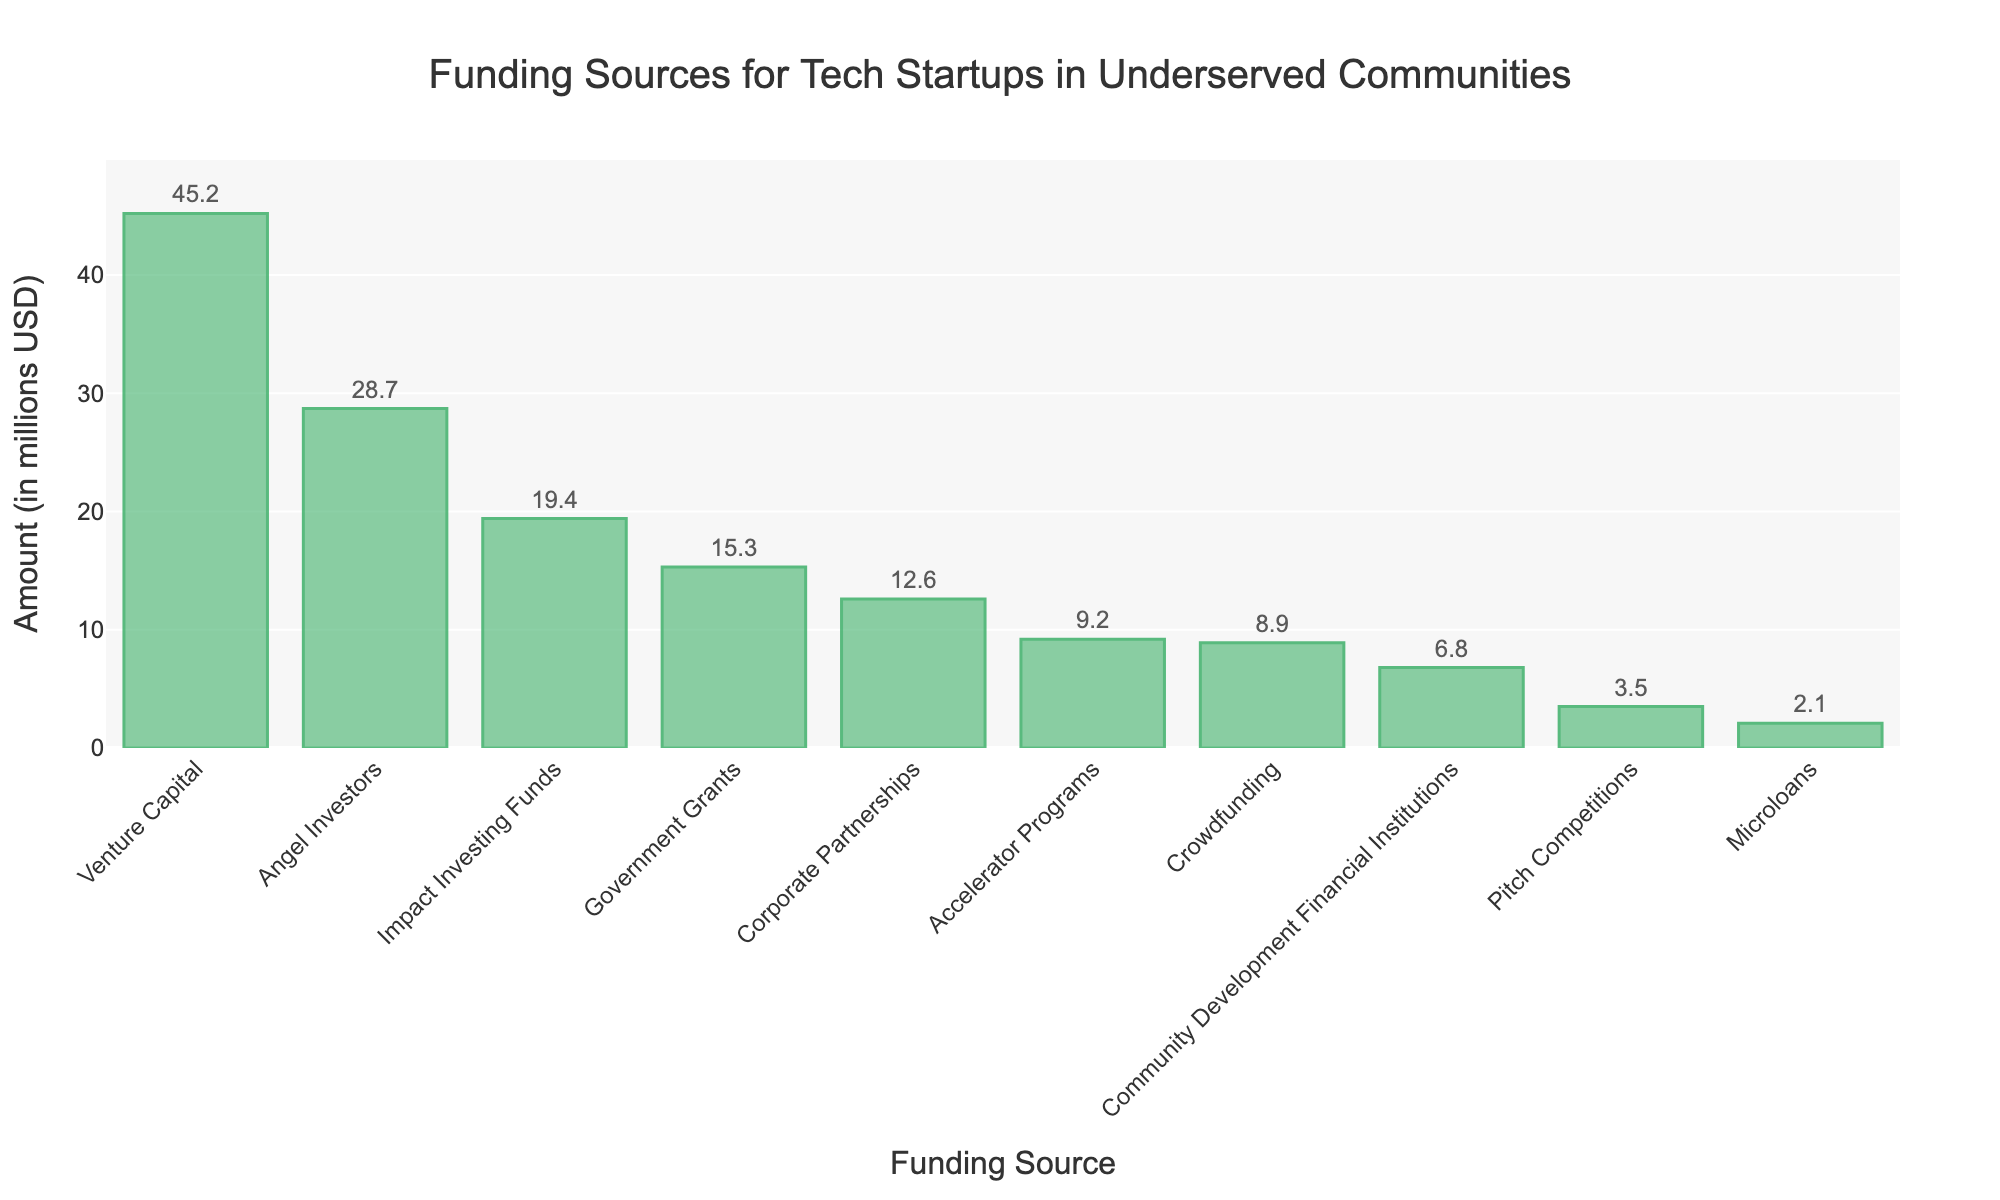Which funding source received the highest amount? Observe the heights of all the bars. The bar labeled "Venture Capital" is the tallest, indicating it received the highest amount of funding.
Answer: Venture Capital What is the combined amount of funding from Government Grants, Corporate Partnerships, and Crowdfunding? Identify the heights of the bars for Government Grants (15.3 million USD), Corporate Partnerships (12.6 million USD), and Crowdfunding (8.9 million USD). Add these amounts together: 15.3 + 12.6 + 8.9 = 36.8 million USD.
Answer: 36.8 million USD Which funding source received less funding, Angel Investors or Impact Investing Funds? Compare the heights of the bars for Angel Investors and Impact Investing Funds. The bar labeled "Impact Investing Funds" is shorter than the "Angel Investors" bar, indicating it received less funding.
Answer: Impact Investing Funds By how much did the funding from Venture Capital exceed Angel Investors? Find the amounts for Venture Capital (45.2 million USD) and Angel Investors (28.7 million USD). Subtract the smaller amount from the larger amount: 45.2 - 28.7 = 16.5 million USD.
Answer: 16.5 million USD What is the average funding amount for all sources? Sum all the amounts: 45.2 + 28.7 + 15.3 + 8.9 + 12.6 + 19.4 + 6.8 + 3.5 + 9.2 + 2.1 = 151.7 million USD. There are 10 sources, so divide the total by 10: 151.7 / 10 = 15.17 million USD.
Answer: 15.17 million USD Which funding sources received more than 10 million USD but less than 20 million USD? Identify the bars within the range from 10 to 20 million USD: Angel Investors (28.7 million USD) is ruled out, Government Grants (15.3 million USD), Corporate Partnerships (12.6 million USD), and Impact Investing Funds (19.4 million USD) fall in this range.
Answer: Government Grants, Corporate Partnerships, Impact Investing Funds What is the difference in funding between the highest and lowest funded sources? Identify the highest and lowest amounts: Venture Capital (45.2 million USD) and Microloans (2.1 million USD). Subtract the lowest from the highest: 45.2 - 2.1 = 43.1 million USD.
Answer: 43.1 million USD What percentage of the total funding is contributed by Crowdfunding? Calculate the total funding: 151.7 million USD. Find the amount for Crowdfunding (8.9 million USD), then divide and multiply by 100: (8.9 / 151.7) * 100 ≈ 5.87%.
Answer: 5.87% Rank the funding sources in order of the amount received from highest to lowest. Observe the heights of the bars and list them in descending order: Venture Capital (45.2 million USD), Angel Investors (28.7 million USD), Impact Investing Funds (19.4 million USD), Government Grants (15.3 million USD), Corporate Partnerships (12.6 million USD), Accelerator Programs (9.2 million USD), Crowdfunding (8.9 million USD), Community Development Financial Institutions (6.8 million USD), Pitch Competitions (3.5 million USD), Microloans (2.1 million USD).
Answer: Venture Capital, Angel Investors, Impact Investing Funds, Government Grants, Corporate Partnerships, Accelerator Programs, Crowdfunding, Community Development Financial Institutions, Pitch Competitions, Microloans 